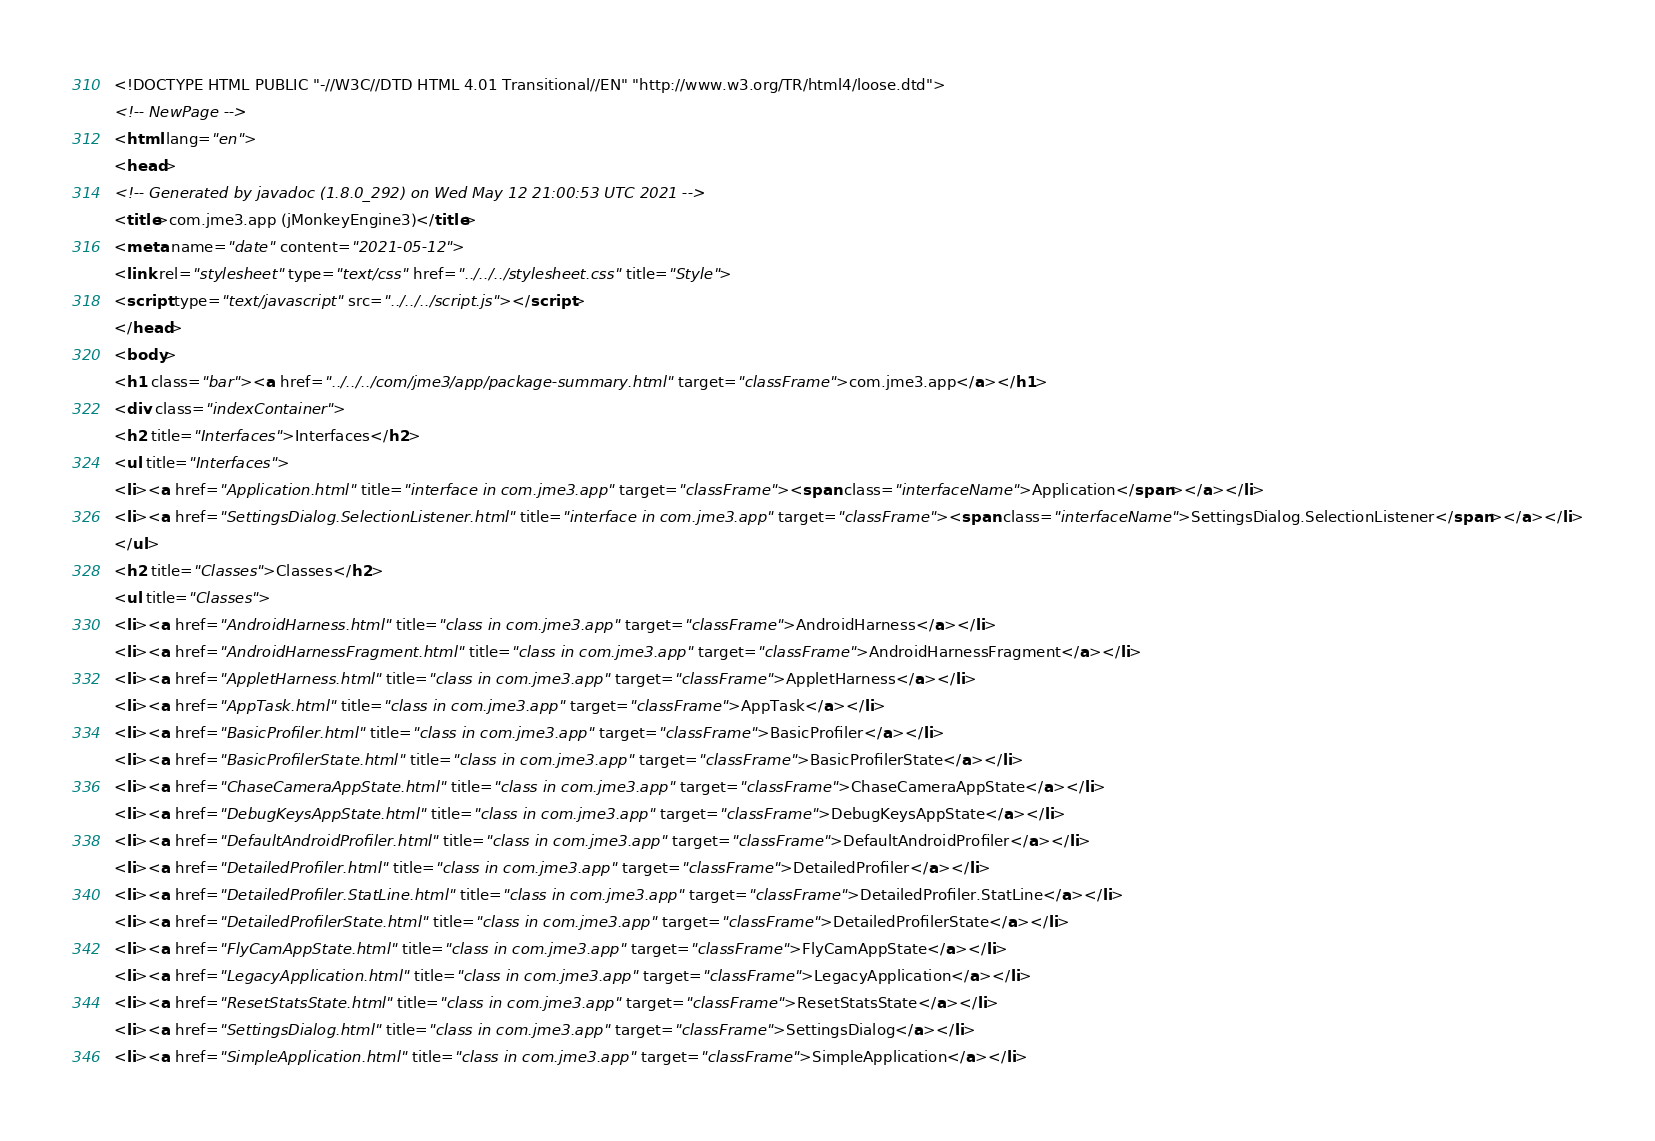Convert code to text. <code><loc_0><loc_0><loc_500><loc_500><_HTML_><!DOCTYPE HTML PUBLIC "-//W3C//DTD HTML 4.01 Transitional//EN" "http://www.w3.org/TR/html4/loose.dtd">
<!-- NewPage -->
<html lang="en">
<head>
<!-- Generated by javadoc (1.8.0_292) on Wed May 12 21:00:53 UTC 2021 -->
<title>com.jme3.app (jMonkeyEngine3)</title>
<meta name="date" content="2021-05-12">
<link rel="stylesheet" type="text/css" href="../../../stylesheet.css" title="Style">
<script type="text/javascript" src="../../../script.js"></script>
</head>
<body>
<h1 class="bar"><a href="../../../com/jme3/app/package-summary.html" target="classFrame">com.jme3.app</a></h1>
<div class="indexContainer">
<h2 title="Interfaces">Interfaces</h2>
<ul title="Interfaces">
<li><a href="Application.html" title="interface in com.jme3.app" target="classFrame"><span class="interfaceName">Application</span></a></li>
<li><a href="SettingsDialog.SelectionListener.html" title="interface in com.jme3.app" target="classFrame"><span class="interfaceName">SettingsDialog.SelectionListener</span></a></li>
</ul>
<h2 title="Classes">Classes</h2>
<ul title="Classes">
<li><a href="AndroidHarness.html" title="class in com.jme3.app" target="classFrame">AndroidHarness</a></li>
<li><a href="AndroidHarnessFragment.html" title="class in com.jme3.app" target="classFrame">AndroidHarnessFragment</a></li>
<li><a href="AppletHarness.html" title="class in com.jme3.app" target="classFrame">AppletHarness</a></li>
<li><a href="AppTask.html" title="class in com.jme3.app" target="classFrame">AppTask</a></li>
<li><a href="BasicProfiler.html" title="class in com.jme3.app" target="classFrame">BasicProfiler</a></li>
<li><a href="BasicProfilerState.html" title="class in com.jme3.app" target="classFrame">BasicProfilerState</a></li>
<li><a href="ChaseCameraAppState.html" title="class in com.jme3.app" target="classFrame">ChaseCameraAppState</a></li>
<li><a href="DebugKeysAppState.html" title="class in com.jme3.app" target="classFrame">DebugKeysAppState</a></li>
<li><a href="DefaultAndroidProfiler.html" title="class in com.jme3.app" target="classFrame">DefaultAndroidProfiler</a></li>
<li><a href="DetailedProfiler.html" title="class in com.jme3.app" target="classFrame">DetailedProfiler</a></li>
<li><a href="DetailedProfiler.StatLine.html" title="class in com.jme3.app" target="classFrame">DetailedProfiler.StatLine</a></li>
<li><a href="DetailedProfilerState.html" title="class in com.jme3.app" target="classFrame">DetailedProfilerState</a></li>
<li><a href="FlyCamAppState.html" title="class in com.jme3.app" target="classFrame">FlyCamAppState</a></li>
<li><a href="LegacyApplication.html" title="class in com.jme3.app" target="classFrame">LegacyApplication</a></li>
<li><a href="ResetStatsState.html" title="class in com.jme3.app" target="classFrame">ResetStatsState</a></li>
<li><a href="SettingsDialog.html" title="class in com.jme3.app" target="classFrame">SettingsDialog</a></li>
<li><a href="SimpleApplication.html" title="class in com.jme3.app" target="classFrame">SimpleApplication</a></li></code> 